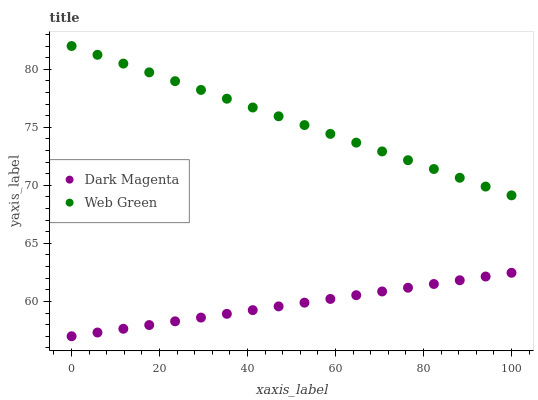Does Dark Magenta have the minimum area under the curve?
Answer yes or no. Yes. Does Web Green have the maximum area under the curve?
Answer yes or no. Yes. Does Web Green have the minimum area under the curve?
Answer yes or no. No. Is Dark Magenta the smoothest?
Answer yes or no. Yes. Is Web Green the roughest?
Answer yes or no. Yes. Is Web Green the smoothest?
Answer yes or no. No. Does Dark Magenta have the lowest value?
Answer yes or no. Yes. Does Web Green have the lowest value?
Answer yes or no. No. Does Web Green have the highest value?
Answer yes or no. Yes. Is Dark Magenta less than Web Green?
Answer yes or no. Yes. Is Web Green greater than Dark Magenta?
Answer yes or no. Yes. Does Dark Magenta intersect Web Green?
Answer yes or no. No. 